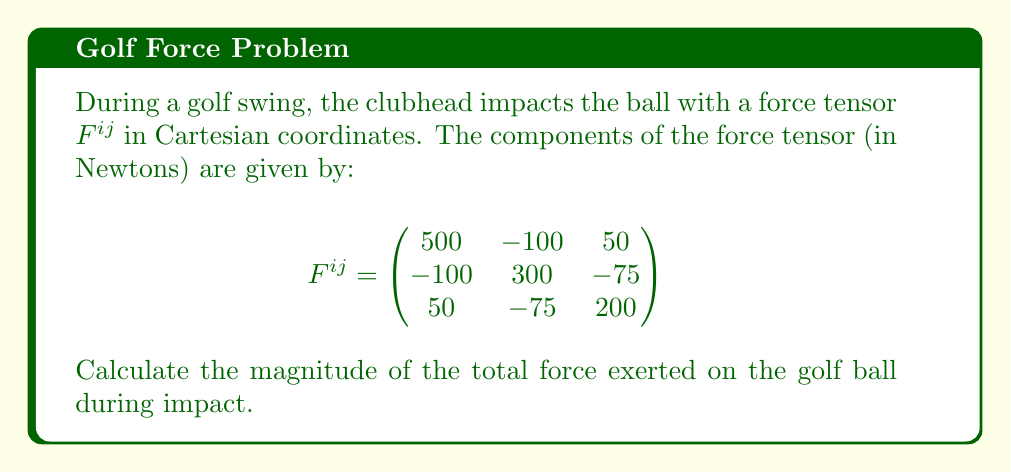What is the answer to this math problem? To find the magnitude of the total force exerted on the golf ball, we need to follow these steps:

1) The force tensor $F^{ij}$ represents the components of force in different directions. To find the total force vector, we need to sum the components in each direction.

2) The total force vector $\vec{F}$ is given by:

   $\vec{F} = (F^{11} + F^{12} + F^{13})\hat{i} + (F^{21} + F^{22} + F^{23})\hat{j} + (F^{31} + F^{32} + F^{33})\hat{k}$

3) Substituting the values:

   $\vec{F} = (500 - 100 + 50)\hat{i} + (-100 + 300 - 75)\hat{j} + (50 - 75 + 200)\hat{k}$

4) Simplifying:

   $\vec{F} = 450\hat{i} + 125\hat{j} + 175\hat{k}$

5) To find the magnitude of this force vector, we use the Pythagorean theorem in 3D:

   $|\vec{F}| = \sqrt{(450)^2 + (125)^2 + (175)^2}$

6) Calculating:

   $|\vec{F}| = \sqrt{202,500 + 15,625 + 30,625}$
   $|\vec{F}| = \sqrt{248,750}$
   $|\vec{F}| \approx 498.75$ N

Therefore, the magnitude of the total force exerted on the golf ball during impact is approximately 498.75 Newtons.
Answer: $498.75$ N 